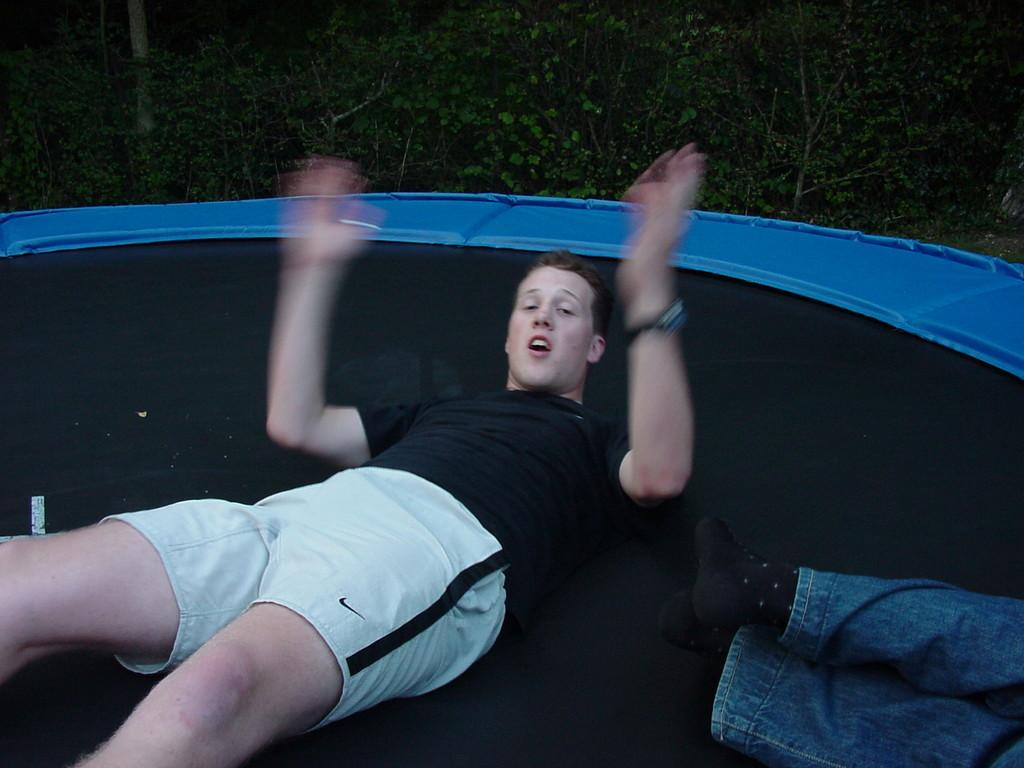How many people are on the jumping bed in the image? There are two persons on the jumping bed in the image. Where is the jumping bed located in the image? The jumping bed is at the bottom of the image. What can be seen in the background of the image? There are plants in the background of the image. Reasoning: Let'g: Let's think step by step in order to produce the conversation. We start by identifying the main subjects in the image, which are the two persons on the jumping bed. Then, we describe the location of the jumping bed, which is at the bottom of the image. Finally, we mention the presence of plants in the background, which provides context about the setting. Absurd Question/Answer: How many frogs are hopping around the seashore in the image? There are no frogs or seashore present in the image; it features two persons on a jumping bed. 